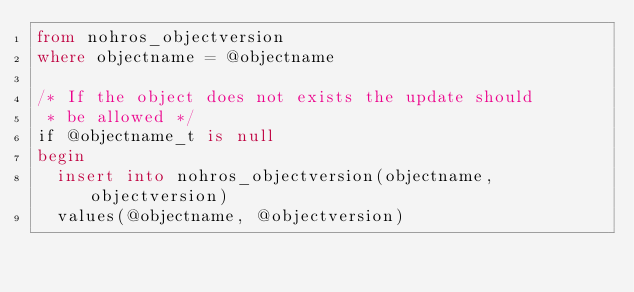<code> <loc_0><loc_0><loc_500><loc_500><_SQL_>from nohros_objectversion
where objectname = @objectname

/* If the object does not exists the update should
 * be allowed */
if @objectname_t is null
begin
  insert into nohros_objectversion(objectname, objectversion)
  values(@objectname, @objectversion)
</code> 